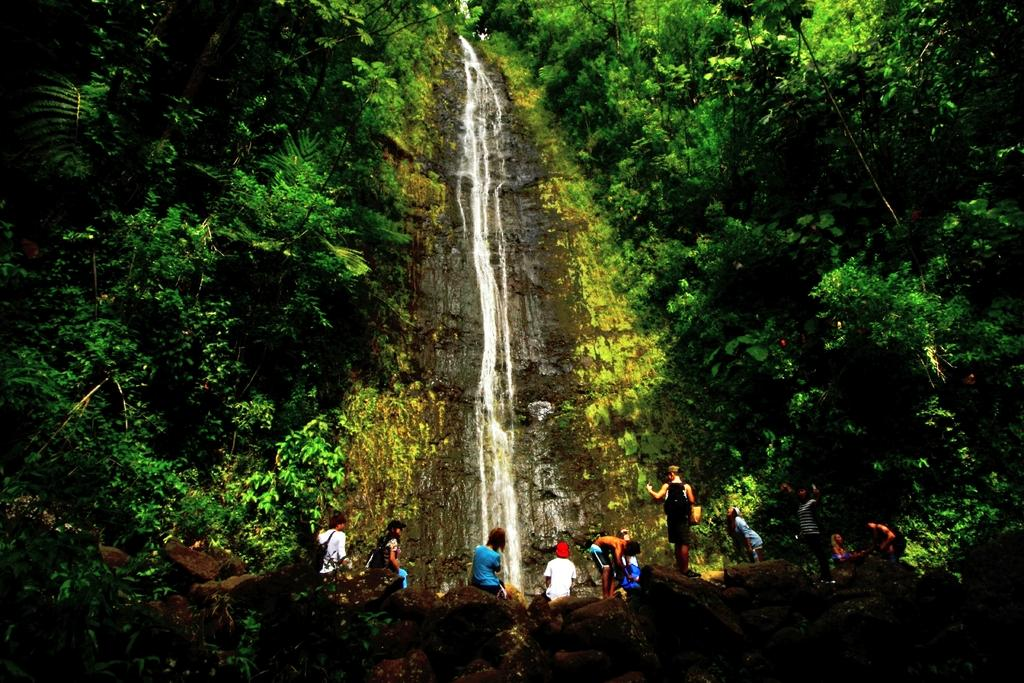What natural feature is the main subject of the image? There is a waterfall in the image. What type of vegetation surrounds the waterfall? There are huge trees on both sides of the waterfall. Where are the boys in the image located? The group of boys is sitting at the bottom of the image, watching the waterfall. What month is it in the image? The month cannot be determined from the image, as there is no information about the time of year. Is there any quicksand present in the image? There is no quicksand present in the image; it features a waterfall and trees. 